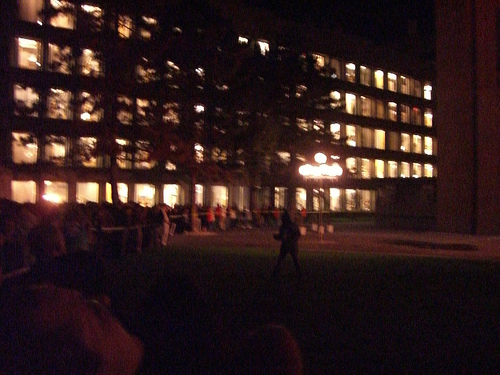<image>
Is the lights in the building? Yes. The lights is contained within or inside the building, showing a containment relationship. 